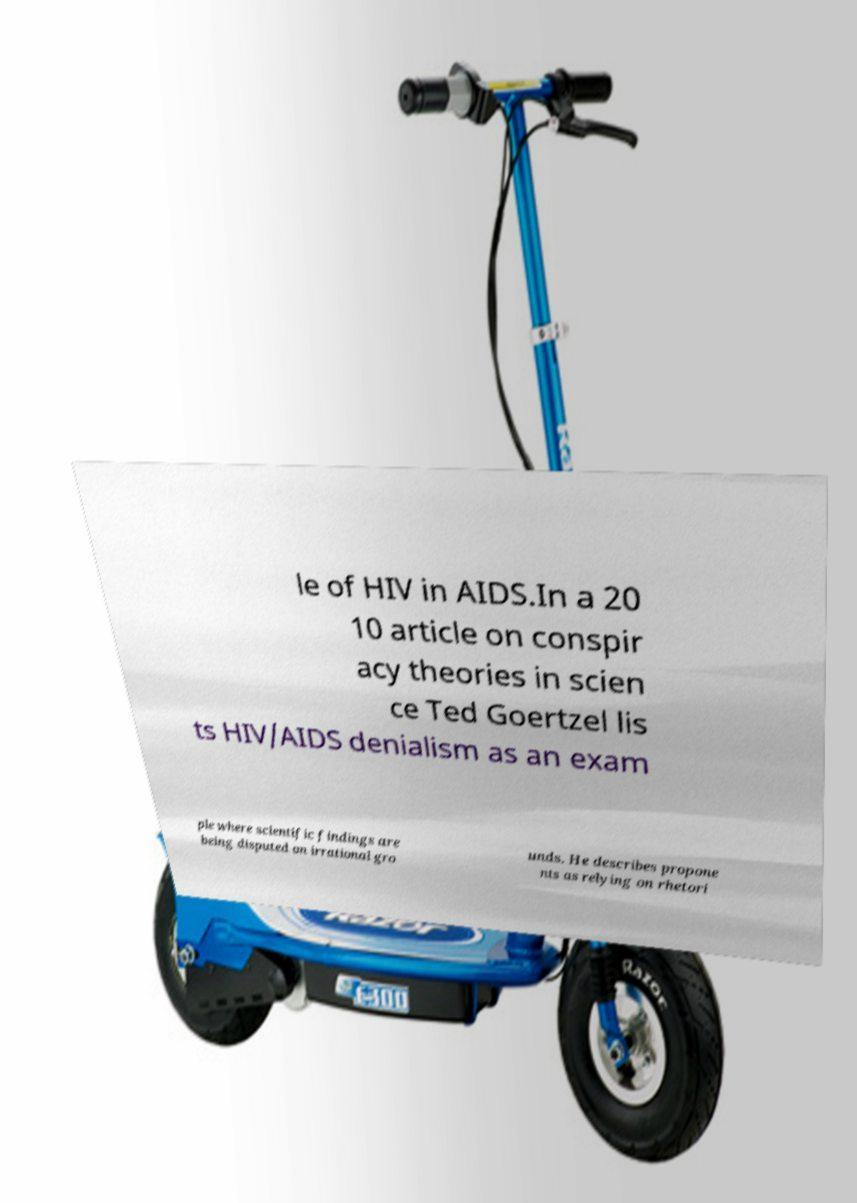Can you read and provide the text displayed in the image?This photo seems to have some interesting text. Can you extract and type it out for me? le of HIV in AIDS.In a 20 10 article on conspir acy theories in scien ce Ted Goertzel lis ts HIV/AIDS denialism as an exam ple where scientific findings are being disputed on irrational gro unds. He describes propone nts as relying on rhetori 